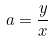Convert formula to latex. <formula><loc_0><loc_0><loc_500><loc_500>a = \frac { y } { x }</formula> 